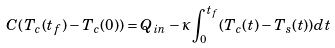<formula> <loc_0><loc_0><loc_500><loc_500>C ( T _ { c } ( t _ { f } ) - T _ { c } ( 0 ) ) = Q _ { i n } - \kappa \int _ { 0 } ^ { t _ { f } } ( T _ { c } ( t ) - T _ { s } ( t ) ) d t</formula> 